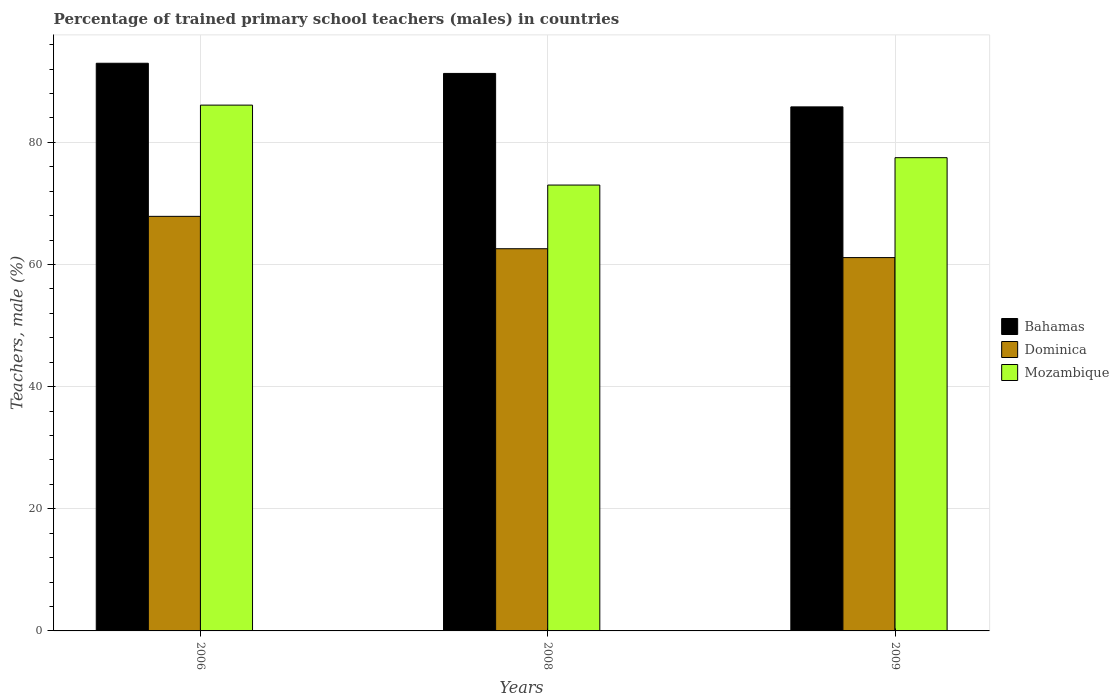How many different coloured bars are there?
Your answer should be compact. 3. How many bars are there on the 2nd tick from the right?
Offer a very short reply. 3. What is the label of the 3rd group of bars from the left?
Your response must be concise. 2009. In how many cases, is the number of bars for a given year not equal to the number of legend labels?
Your answer should be very brief. 0. What is the percentage of trained primary school teachers (males) in Dominica in 2008?
Your answer should be compact. 62.59. Across all years, what is the maximum percentage of trained primary school teachers (males) in Dominica?
Keep it short and to the point. 67.89. Across all years, what is the minimum percentage of trained primary school teachers (males) in Dominica?
Offer a very short reply. 61.14. What is the total percentage of trained primary school teachers (males) in Mozambique in the graph?
Ensure brevity in your answer.  236.61. What is the difference between the percentage of trained primary school teachers (males) in Dominica in 2006 and that in 2008?
Give a very brief answer. 5.3. What is the difference between the percentage of trained primary school teachers (males) in Bahamas in 2009 and the percentage of trained primary school teachers (males) in Mozambique in 2006?
Provide a succinct answer. -0.29. What is the average percentage of trained primary school teachers (males) in Mozambique per year?
Provide a short and direct response. 78.87. In the year 2008, what is the difference between the percentage of trained primary school teachers (males) in Bahamas and percentage of trained primary school teachers (males) in Dominica?
Offer a very short reply. 28.71. What is the ratio of the percentage of trained primary school teachers (males) in Mozambique in 2006 to that in 2009?
Provide a short and direct response. 1.11. What is the difference between the highest and the second highest percentage of trained primary school teachers (males) in Bahamas?
Your response must be concise. 1.67. What is the difference between the highest and the lowest percentage of trained primary school teachers (males) in Mozambique?
Ensure brevity in your answer.  13.09. In how many years, is the percentage of trained primary school teachers (males) in Bahamas greater than the average percentage of trained primary school teachers (males) in Bahamas taken over all years?
Your answer should be compact. 2. Is the sum of the percentage of trained primary school teachers (males) in Mozambique in 2008 and 2009 greater than the maximum percentage of trained primary school teachers (males) in Dominica across all years?
Your answer should be compact. Yes. What does the 1st bar from the left in 2006 represents?
Offer a terse response. Bahamas. What does the 2nd bar from the right in 2008 represents?
Make the answer very short. Dominica. Is it the case that in every year, the sum of the percentage of trained primary school teachers (males) in Bahamas and percentage of trained primary school teachers (males) in Mozambique is greater than the percentage of trained primary school teachers (males) in Dominica?
Your response must be concise. Yes. How many bars are there?
Make the answer very short. 9. What is the title of the graph?
Offer a very short reply. Percentage of trained primary school teachers (males) in countries. Does "Bosnia and Herzegovina" appear as one of the legend labels in the graph?
Give a very brief answer. No. What is the label or title of the X-axis?
Provide a short and direct response. Years. What is the label or title of the Y-axis?
Make the answer very short. Teachers, male (%). What is the Teachers, male (%) of Bahamas in 2006?
Your answer should be very brief. 92.96. What is the Teachers, male (%) in Dominica in 2006?
Your response must be concise. 67.89. What is the Teachers, male (%) in Mozambique in 2006?
Give a very brief answer. 86.1. What is the Teachers, male (%) in Bahamas in 2008?
Give a very brief answer. 91.29. What is the Teachers, male (%) in Dominica in 2008?
Your answer should be very brief. 62.59. What is the Teachers, male (%) of Mozambique in 2008?
Provide a short and direct response. 73.01. What is the Teachers, male (%) in Bahamas in 2009?
Your answer should be very brief. 85.82. What is the Teachers, male (%) in Dominica in 2009?
Your response must be concise. 61.14. What is the Teachers, male (%) in Mozambique in 2009?
Make the answer very short. 77.5. Across all years, what is the maximum Teachers, male (%) of Bahamas?
Your answer should be very brief. 92.96. Across all years, what is the maximum Teachers, male (%) in Dominica?
Offer a very short reply. 67.89. Across all years, what is the maximum Teachers, male (%) in Mozambique?
Your response must be concise. 86.1. Across all years, what is the minimum Teachers, male (%) of Bahamas?
Your answer should be very brief. 85.82. Across all years, what is the minimum Teachers, male (%) in Dominica?
Provide a short and direct response. 61.14. Across all years, what is the minimum Teachers, male (%) in Mozambique?
Your response must be concise. 73.01. What is the total Teachers, male (%) of Bahamas in the graph?
Your answer should be very brief. 270.07. What is the total Teachers, male (%) in Dominica in the graph?
Provide a short and direct response. 191.61. What is the total Teachers, male (%) of Mozambique in the graph?
Provide a succinct answer. 236.61. What is the difference between the Teachers, male (%) in Bahamas in 2006 and that in 2008?
Offer a terse response. 1.67. What is the difference between the Teachers, male (%) in Dominica in 2006 and that in 2008?
Provide a short and direct response. 5.3. What is the difference between the Teachers, male (%) in Mozambique in 2006 and that in 2008?
Your response must be concise. 13.09. What is the difference between the Teachers, male (%) of Bahamas in 2006 and that in 2009?
Offer a terse response. 7.14. What is the difference between the Teachers, male (%) of Dominica in 2006 and that in 2009?
Your answer should be compact. 6.75. What is the difference between the Teachers, male (%) of Mozambique in 2006 and that in 2009?
Provide a succinct answer. 8.61. What is the difference between the Teachers, male (%) in Bahamas in 2008 and that in 2009?
Your answer should be very brief. 5.48. What is the difference between the Teachers, male (%) of Dominica in 2008 and that in 2009?
Provide a succinct answer. 1.45. What is the difference between the Teachers, male (%) of Mozambique in 2008 and that in 2009?
Your answer should be very brief. -4.48. What is the difference between the Teachers, male (%) of Bahamas in 2006 and the Teachers, male (%) of Dominica in 2008?
Your answer should be compact. 30.37. What is the difference between the Teachers, male (%) of Bahamas in 2006 and the Teachers, male (%) of Mozambique in 2008?
Give a very brief answer. 19.95. What is the difference between the Teachers, male (%) in Dominica in 2006 and the Teachers, male (%) in Mozambique in 2008?
Your answer should be compact. -5.12. What is the difference between the Teachers, male (%) in Bahamas in 2006 and the Teachers, male (%) in Dominica in 2009?
Make the answer very short. 31.82. What is the difference between the Teachers, male (%) of Bahamas in 2006 and the Teachers, male (%) of Mozambique in 2009?
Make the answer very short. 15.46. What is the difference between the Teachers, male (%) in Dominica in 2006 and the Teachers, male (%) in Mozambique in 2009?
Ensure brevity in your answer.  -9.61. What is the difference between the Teachers, male (%) of Bahamas in 2008 and the Teachers, male (%) of Dominica in 2009?
Provide a succinct answer. 30.16. What is the difference between the Teachers, male (%) of Bahamas in 2008 and the Teachers, male (%) of Mozambique in 2009?
Provide a succinct answer. 13.8. What is the difference between the Teachers, male (%) of Dominica in 2008 and the Teachers, male (%) of Mozambique in 2009?
Ensure brevity in your answer.  -14.91. What is the average Teachers, male (%) of Bahamas per year?
Make the answer very short. 90.02. What is the average Teachers, male (%) in Dominica per year?
Ensure brevity in your answer.  63.87. What is the average Teachers, male (%) of Mozambique per year?
Keep it short and to the point. 78.87. In the year 2006, what is the difference between the Teachers, male (%) of Bahamas and Teachers, male (%) of Dominica?
Offer a very short reply. 25.07. In the year 2006, what is the difference between the Teachers, male (%) in Bahamas and Teachers, male (%) in Mozambique?
Your response must be concise. 6.86. In the year 2006, what is the difference between the Teachers, male (%) of Dominica and Teachers, male (%) of Mozambique?
Your answer should be compact. -18.21. In the year 2008, what is the difference between the Teachers, male (%) of Bahamas and Teachers, male (%) of Dominica?
Your answer should be very brief. 28.71. In the year 2008, what is the difference between the Teachers, male (%) in Bahamas and Teachers, male (%) in Mozambique?
Offer a very short reply. 18.28. In the year 2008, what is the difference between the Teachers, male (%) in Dominica and Teachers, male (%) in Mozambique?
Ensure brevity in your answer.  -10.43. In the year 2009, what is the difference between the Teachers, male (%) in Bahamas and Teachers, male (%) in Dominica?
Give a very brief answer. 24.68. In the year 2009, what is the difference between the Teachers, male (%) in Bahamas and Teachers, male (%) in Mozambique?
Your answer should be compact. 8.32. In the year 2009, what is the difference between the Teachers, male (%) in Dominica and Teachers, male (%) in Mozambique?
Your response must be concise. -16.36. What is the ratio of the Teachers, male (%) in Bahamas in 2006 to that in 2008?
Make the answer very short. 1.02. What is the ratio of the Teachers, male (%) of Dominica in 2006 to that in 2008?
Your response must be concise. 1.08. What is the ratio of the Teachers, male (%) in Mozambique in 2006 to that in 2008?
Provide a succinct answer. 1.18. What is the ratio of the Teachers, male (%) of Bahamas in 2006 to that in 2009?
Your response must be concise. 1.08. What is the ratio of the Teachers, male (%) of Dominica in 2006 to that in 2009?
Give a very brief answer. 1.11. What is the ratio of the Teachers, male (%) in Mozambique in 2006 to that in 2009?
Give a very brief answer. 1.11. What is the ratio of the Teachers, male (%) in Bahamas in 2008 to that in 2009?
Your response must be concise. 1.06. What is the ratio of the Teachers, male (%) in Dominica in 2008 to that in 2009?
Provide a short and direct response. 1.02. What is the ratio of the Teachers, male (%) in Mozambique in 2008 to that in 2009?
Your answer should be compact. 0.94. What is the difference between the highest and the second highest Teachers, male (%) in Bahamas?
Provide a short and direct response. 1.67. What is the difference between the highest and the second highest Teachers, male (%) of Dominica?
Offer a very short reply. 5.3. What is the difference between the highest and the second highest Teachers, male (%) in Mozambique?
Give a very brief answer. 8.61. What is the difference between the highest and the lowest Teachers, male (%) in Bahamas?
Give a very brief answer. 7.14. What is the difference between the highest and the lowest Teachers, male (%) of Dominica?
Ensure brevity in your answer.  6.75. What is the difference between the highest and the lowest Teachers, male (%) in Mozambique?
Keep it short and to the point. 13.09. 